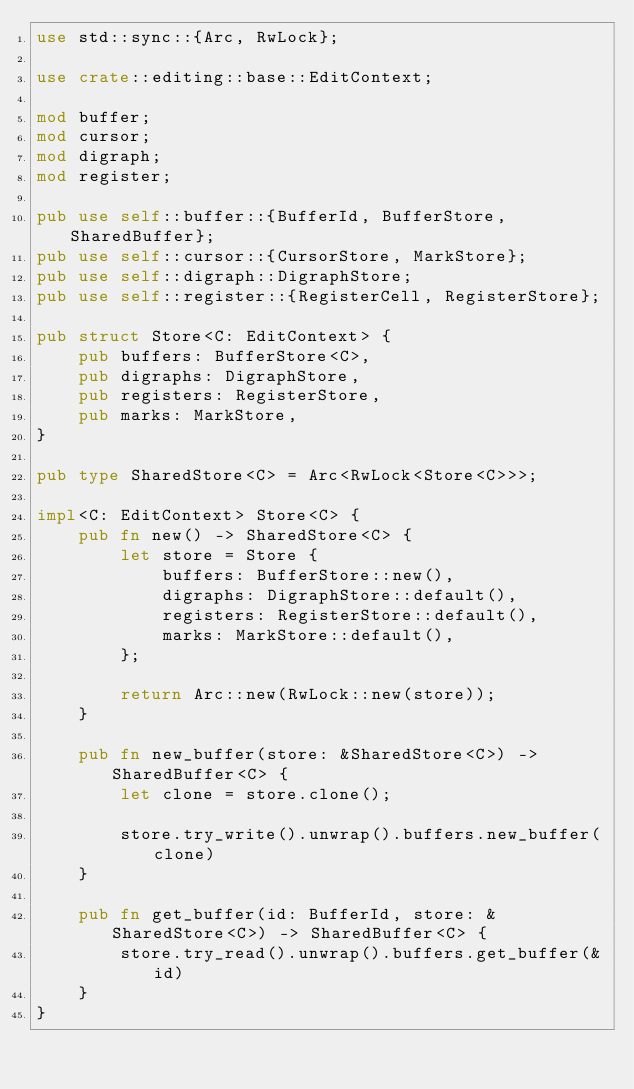Convert code to text. <code><loc_0><loc_0><loc_500><loc_500><_Rust_>use std::sync::{Arc, RwLock};

use crate::editing::base::EditContext;

mod buffer;
mod cursor;
mod digraph;
mod register;

pub use self::buffer::{BufferId, BufferStore, SharedBuffer};
pub use self::cursor::{CursorStore, MarkStore};
pub use self::digraph::DigraphStore;
pub use self::register::{RegisterCell, RegisterStore};

pub struct Store<C: EditContext> {
    pub buffers: BufferStore<C>,
    pub digraphs: DigraphStore,
    pub registers: RegisterStore,
    pub marks: MarkStore,
}

pub type SharedStore<C> = Arc<RwLock<Store<C>>>;

impl<C: EditContext> Store<C> {
    pub fn new() -> SharedStore<C> {
        let store = Store {
            buffers: BufferStore::new(),
            digraphs: DigraphStore::default(),
            registers: RegisterStore::default(),
            marks: MarkStore::default(),
        };

        return Arc::new(RwLock::new(store));
    }

    pub fn new_buffer(store: &SharedStore<C>) -> SharedBuffer<C> {
        let clone = store.clone();

        store.try_write().unwrap().buffers.new_buffer(clone)
    }

    pub fn get_buffer(id: BufferId, store: &SharedStore<C>) -> SharedBuffer<C> {
        store.try_read().unwrap().buffers.get_buffer(&id)
    }
}
</code> 